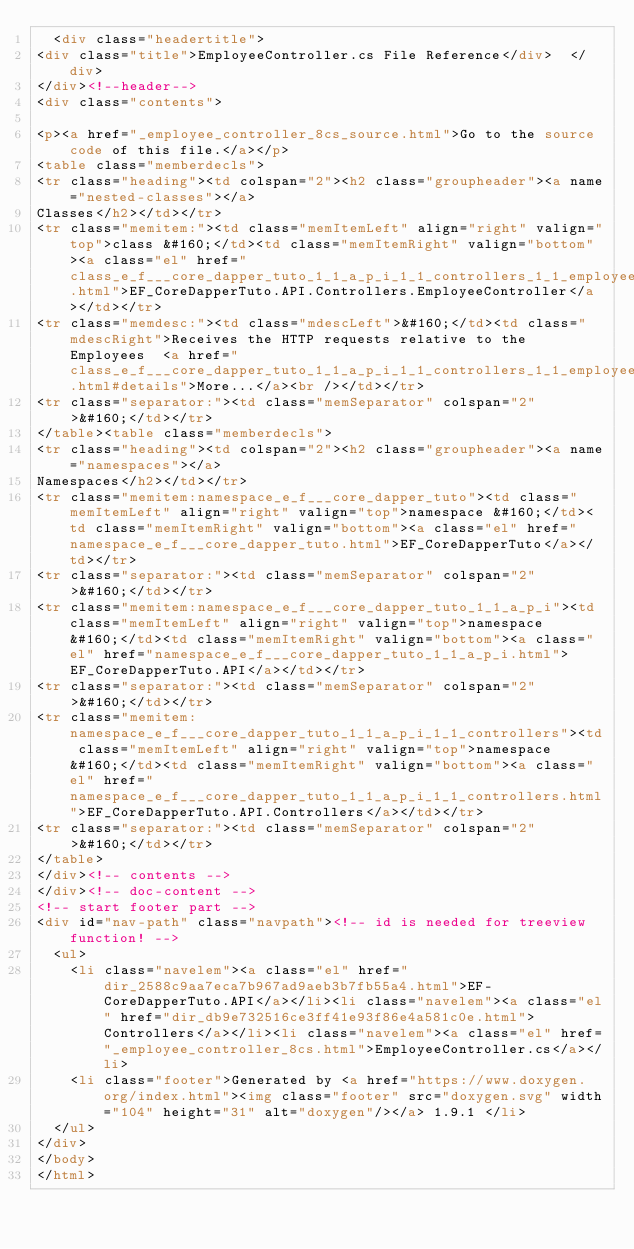<code> <loc_0><loc_0><loc_500><loc_500><_HTML_>  <div class="headertitle">
<div class="title">EmployeeController.cs File Reference</div>  </div>
</div><!--header-->
<div class="contents">

<p><a href="_employee_controller_8cs_source.html">Go to the source code of this file.</a></p>
<table class="memberdecls">
<tr class="heading"><td colspan="2"><h2 class="groupheader"><a name="nested-classes"></a>
Classes</h2></td></tr>
<tr class="memitem:"><td class="memItemLeft" align="right" valign="top">class &#160;</td><td class="memItemRight" valign="bottom"><a class="el" href="class_e_f___core_dapper_tuto_1_1_a_p_i_1_1_controllers_1_1_employee_controller.html">EF_CoreDapperTuto.API.Controllers.EmployeeController</a></td></tr>
<tr class="memdesc:"><td class="mdescLeft">&#160;</td><td class="mdescRight">Receives the HTTP requests relative to the Employees  <a href="class_e_f___core_dapper_tuto_1_1_a_p_i_1_1_controllers_1_1_employee_controller.html#details">More...</a><br /></td></tr>
<tr class="separator:"><td class="memSeparator" colspan="2">&#160;</td></tr>
</table><table class="memberdecls">
<tr class="heading"><td colspan="2"><h2 class="groupheader"><a name="namespaces"></a>
Namespaces</h2></td></tr>
<tr class="memitem:namespace_e_f___core_dapper_tuto"><td class="memItemLeft" align="right" valign="top">namespace &#160;</td><td class="memItemRight" valign="bottom"><a class="el" href="namespace_e_f___core_dapper_tuto.html">EF_CoreDapperTuto</a></td></tr>
<tr class="separator:"><td class="memSeparator" colspan="2">&#160;</td></tr>
<tr class="memitem:namespace_e_f___core_dapper_tuto_1_1_a_p_i"><td class="memItemLeft" align="right" valign="top">namespace &#160;</td><td class="memItemRight" valign="bottom"><a class="el" href="namespace_e_f___core_dapper_tuto_1_1_a_p_i.html">EF_CoreDapperTuto.API</a></td></tr>
<tr class="separator:"><td class="memSeparator" colspan="2">&#160;</td></tr>
<tr class="memitem:namespace_e_f___core_dapper_tuto_1_1_a_p_i_1_1_controllers"><td class="memItemLeft" align="right" valign="top">namespace &#160;</td><td class="memItemRight" valign="bottom"><a class="el" href="namespace_e_f___core_dapper_tuto_1_1_a_p_i_1_1_controllers.html">EF_CoreDapperTuto.API.Controllers</a></td></tr>
<tr class="separator:"><td class="memSeparator" colspan="2">&#160;</td></tr>
</table>
</div><!-- contents -->
</div><!-- doc-content -->
<!-- start footer part -->
<div id="nav-path" class="navpath"><!-- id is needed for treeview function! -->
  <ul>
    <li class="navelem"><a class="el" href="dir_2588c9aa7eca7b967ad9aeb3b7fb55a4.html">EF-CoreDapperTuto.API</a></li><li class="navelem"><a class="el" href="dir_db9e732516ce3ff41e93f86e4a581c0e.html">Controllers</a></li><li class="navelem"><a class="el" href="_employee_controller_8cs.html">EmployeeController.cs</a></li>
    <li class="footer">Generated by <a href="https://www.doxygen.org/index.html"><img class="footer" src="doxygen.svg" width="104" height="31" alt="doxygen"/></a> 1.9.1 </li>
  </ul>
</div>
</body>
</html>
</code> 